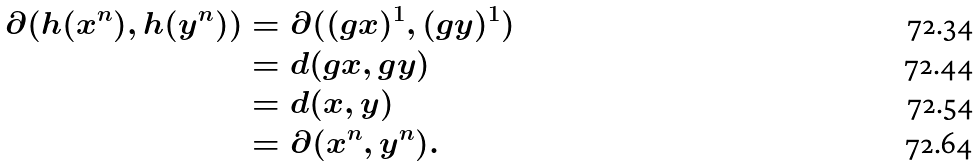<formula> <loc_0><loc_0><loc_500><loc_500>\partial ( h ( x ^ { n } ) , h ( y ^ { n } ) ) & = \partial ( ( g x ) ^ { 1 } , ( g y ) ^ { 1 } ) \\ & = d ( g x , g y ) \\ & = d ( x , y ) \\ & = \partial ( x ^ { n } , y ^ { n } ) .</formula> 